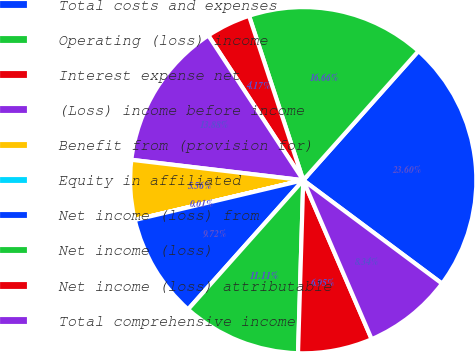<chart> <loc_0><loc_0><loc_500><loc_500><pie_chart><fcel>Total costs and expenses<fcel>Operating (loss) income<fcel>Interest expense net<fcel>(Loss) income before income<fcel>Benefit from (provision for)<fcel>Equity in affiliated<fcel>Net income (loss) from<fcel>Net income (loss)<fcel>Net income (loss) attributable<fcel>Total comprehensive income<nl><fcel>23.6%<fcel>16.66%<fcel>4.17%<fcel>13.88%<fcel>5.56%<fcel>0.01%<fcel>9.72%<fcel>11.11%<fcel>6.95%<fcel>8.34%<nl></chart> 